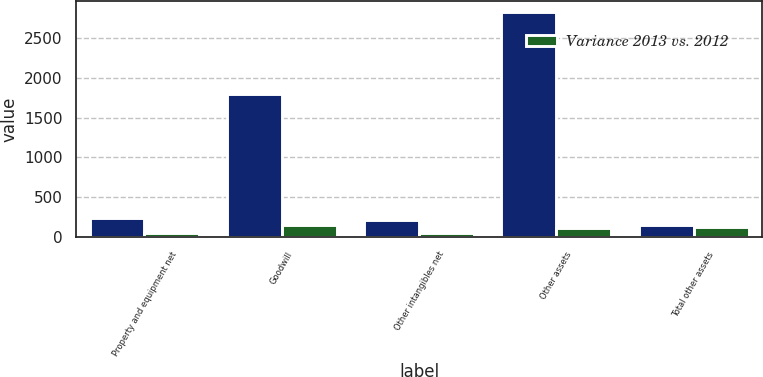Convert chart to OTSL. <chart><loc_0><loc_0><loc_500><loc_500><stacked_bar_chart><ecel><fcel>Property and equipment net<fcel>Goodwill<fcel>Other intangibles net<fcel>Other assets<fcel>Total other assets<nl><fcel>nan<fcel>237.2<fcel>1791.8<fcel>215.9<fcel>2821.2<fcel>142.4<nl><fcel>Variance 2013 vs. 2012<fcel>51<fcel>142.4<fcel>44.7<fcel>110.2<fcel>127.9<nl></chart> 